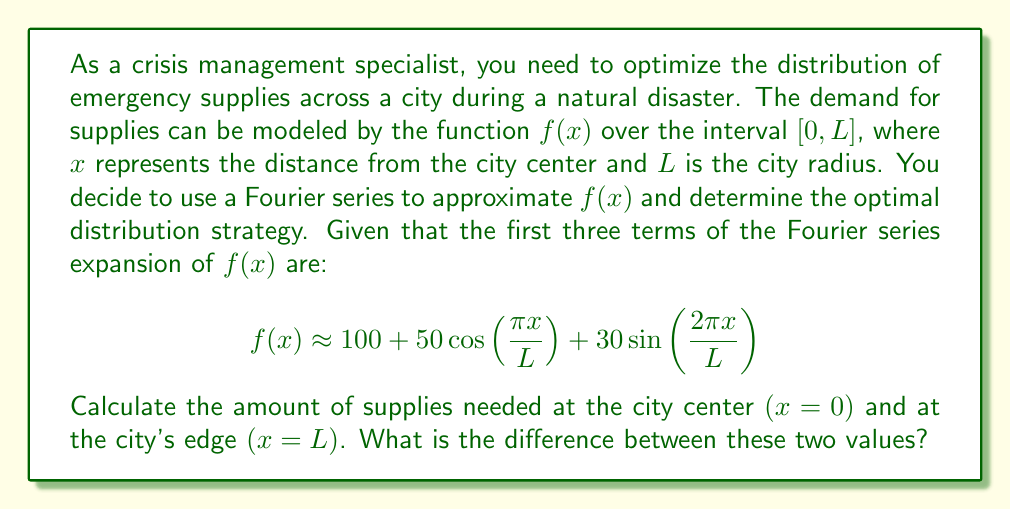Teach me how to tackle this problem. To solve this problem, we need to evaluate the given Fourier series approximation at $x=0$ and $x=L$, then find the difference between these values.

1. At the city center $(x=0)$:
   $$\begin{align*}
   f(0) &= 100 + 50\cos\left(\frac{\pi \cdot 0}{L}\right) + 30\sin\left(\frac{2\pi \cdot 0}{L}\right) \\
   &= 100 + 50\cos(0) + 30\sin(0) \\
   &= 100 + 50 \cdot 1 + 30 \cdot 0 \\
   &= 150
   \end{align*}$$

2. At the city's edge $(x=L)$:
   $$\begin{align*}
   f(L) &= 100 + 50\cos\left(\frac{\pi L}{L}\right) + 30\sin\left(\frac{2\pi L}{L}\right) \\
   &= 100 + 50\cos(\pi) + 30\sin(2\pi) \\
   &= 100 + 50 \cdot (-1) + 30 \cdot 0 \\
   &= 50
   \end{align*}$$

3. The difference between the amount of supplies needed at the city center and the city's edge:
   $$\begin{align*}
   \text{Difference} &= f(0) - f(L) \\
   &= 150 - 50 \\
   &= 100
   \end{align*}$$

This result indicates that the demand for supplies at the city center is 100 units higher than at the city's edge, which is consistent with the expectation that population density and resource needs are typically higher in central urban areas during a crisis.
Answer: The difference in the amount of supplies needed between the city center and the city's edge is 100 units. 